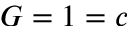<formula> <loc_0><loc_0><loc_500><loc_500>G = 1 = c</formula> 